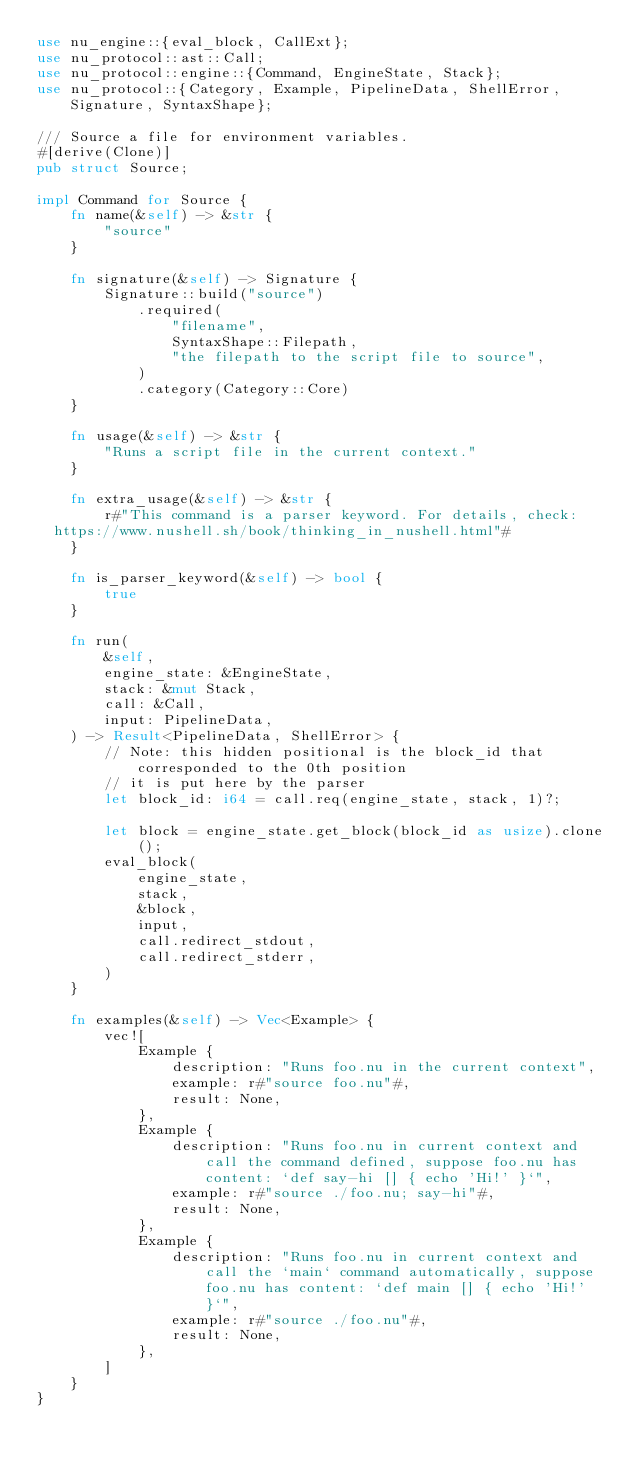<code> <loc_0><loc_0><loc_500><loc_500><_Rust_>use nu_engine::{eval_block, CallExt};
use nu_protocol::ast::Call;
use nu_protocol::engine::{Command, EngineState, Stack};
use nu_protocol::{Category, Example, PipelineData, ShellError, Signature, SyntaxShape};

/// Source a file for environment variables.
#[derive(Clone)]
pub struct Source;

impl Command for Source {
    fn name(&self) -> &str {
        "source"
    }

    fn signature(&self) -> Signature {
        Signature::build("source")
            .required(
                "filename",
                SyntaxShape::Filepath,
                "the filepath to the script file to source",
            )
            .category(Category::Core)
    }

    fn usage(&self) -> &str {
        "Runs a script file in the current context."
    }

    fn extra_usage(&self) -> &str {
        r#"This command is a parser keyword. For details, check:
  https://www.nushell.sh/book/thinking_in_nushell.html"#
    }

    fn is_parser_keyword(&self) -> bool {
        true
    }

    fn run(
        &self,
        engine_state: &EngineState,
        stack: &mut Stack,
        call: &Call,
        input: PipelineData,
    ) -> Result<PipelineData, ShellError> {
        // Note: this hidden positional is the block_id that corresponded to the 0th position
        // it is put here by the parser
        let block_id: i64 = call.req(engine_state, stack, 1)?;

        let block = engine_state.get_block(block_id as usize).clone();
        eval_block(
            engine_state,
            stack,
            &block,
            input,
            call.redirect_stdout,
            call.redirect_stderr,
        )
    }

    fn examples(&self) -> Vec<Example> {
        vec![
            Example {
                description: "Runs foo.nu in the current context",
                example: r#"source foo.nu"#,
                result: None,
            },
            Example {
                description: "Runs foo.nu in current context and call the command defined, suppose foo.nu has content: `def say-hi [] { echo 'Hi!' }`",
                example: r#"source ./foo.nu; say-hi"#,
                result: None,
            },
            Example {
                description: "Runs foo.nu in current context and call the `main` command automatically, suppose foo.nu has content: `def main [] { echo 'Hi!' }`",
                example: r#"source ./foo.nu"#,
                result: None,
            },
        ]
    }
}
</code> 